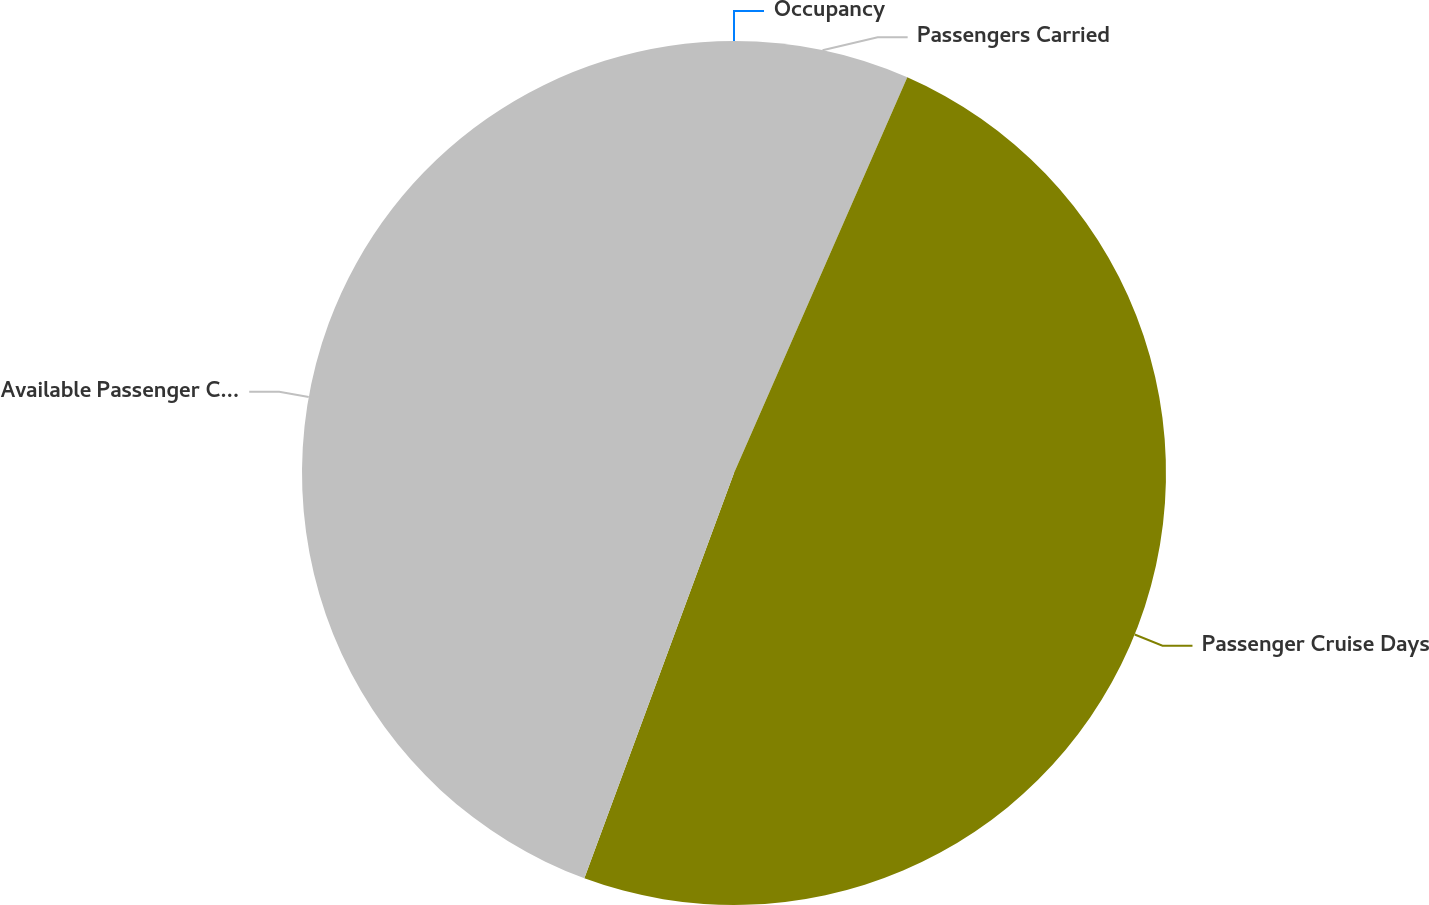<chart> <loc_0><loc_0><loc_500><loc_500><pie_chart><fcel>Passengers Carried<fcel>Passenger Cruise Days<fcel>Available Passenger Cruise<fcel>Occupancy<nl><fcel>6.57%<fcel>49.06%<fcel>44.37%<fcel>0.0%<nl></chart> 